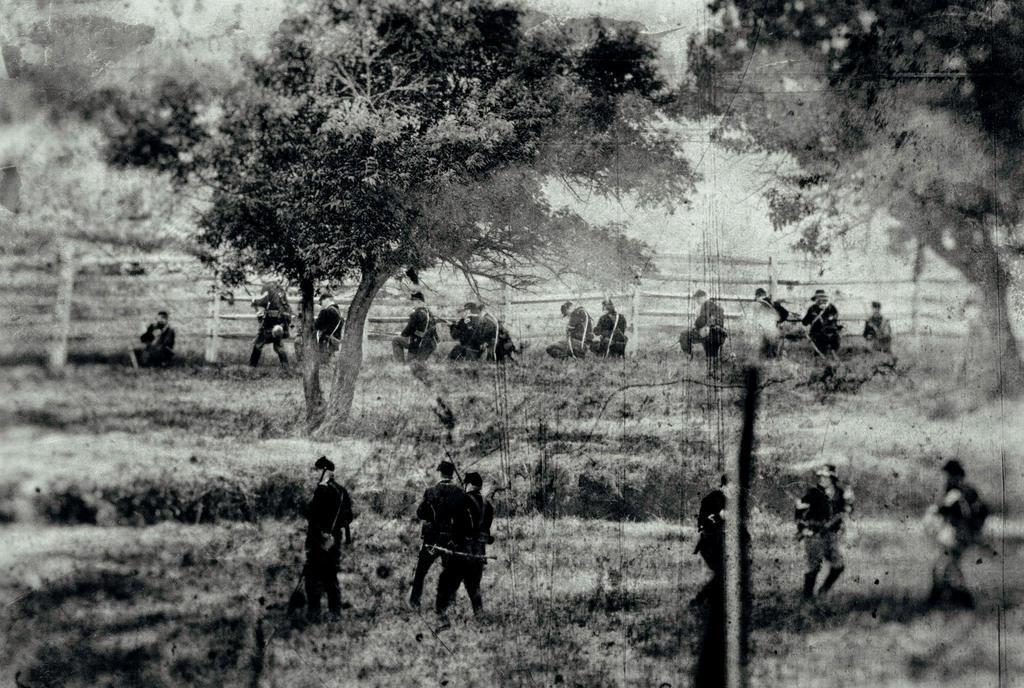Please provide a concise description of this image. In this image I can see group of people some are standing and some are sitting. Background I can see trees, railing and sky, and the image is in black and white. 